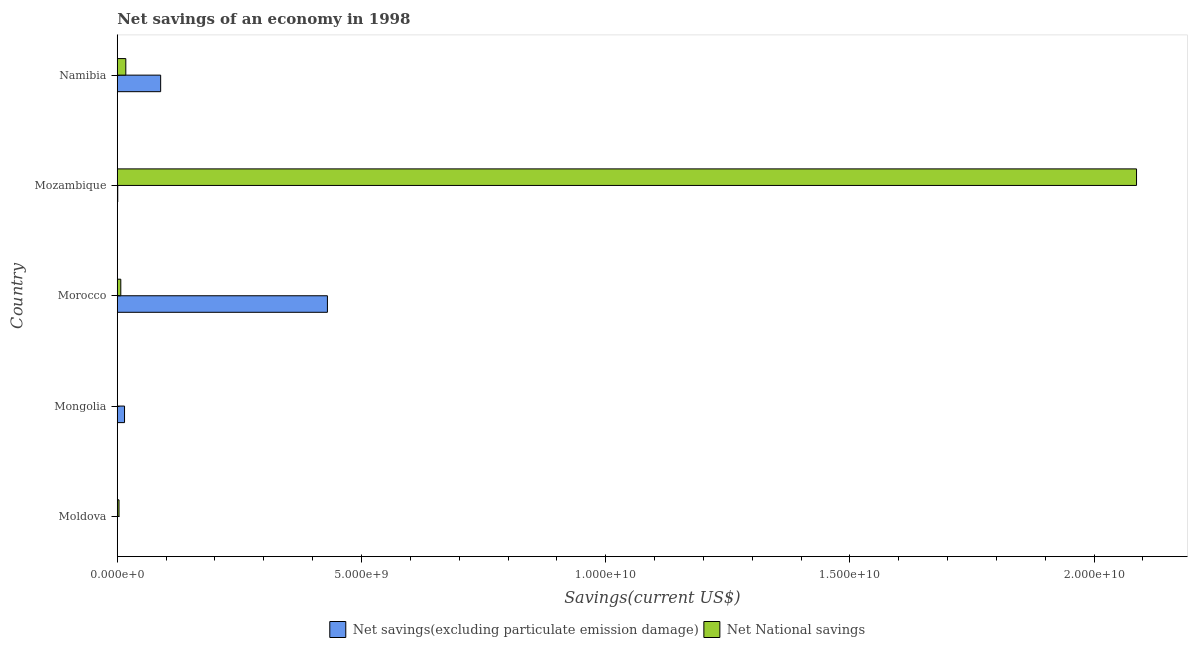How many different coloured bars are there?
Give a very brief answer. 2. Are the number of bars per tick equal to the number of legend labels?
Provide a succinct answer. No. How many bars are there on the 1st tick from the top?
Ensure brevity in your answer.  2. What is the label of the 1st group of bars from the top?
Provide a succinct answer. Namibia. In how many cases, is the number of bars for a given country not equal to the number of legend labels?
Make the answer very short. 2. What is the net national savings in Mongolia?
Keep it short and to the point. 0. Across all countries, what is the maximum net savings(excluding particulate emission damage)?
Give a very brief answer. 4.30e+09. Across all countries, what is the minimum net national savings?
Provide a succinct answer. 0. In which country was the net savings(excluding particulate emission damage) maximum?
Provide a short and direct response. Morocco. What is the total net national savings in the graph?
Your answer should be compact. 2.12e+1. What is the difference between the net savings(excluding particulate emission damage) in Mozambique and that in Namibia?
Offer a very short reply. -8.78e+08. What is the difference between the net national savings in Mongolia and the net savings(excluding particulate emission damage) in Morocco?
Your response must be concise. -4.30e+09. What is the average net national savings per country?
Make the answer very short. 4.23e+09. What is the difference between the net savings(excluding particulate emission damage) and net national savings in Mozambique?
Your response must be concise. -2.09e+1. In how many countries, is the net national savings greater than 14000000000 US$?
Give a very brief answer. 1. What is the ratio of the net national savings in Moldova to that in Namibia?
Your answer should be compact. 0.2. Is the net savings(excluding particulate emission damage) in Morocco less than that in Mozambique?
Offer a terse response. No. What is the difference between the highest and the second highest net national savings?
Offer a very short reply. 2.07e+1. What is the difference between the highest and the lowest net savings(excluding particulate emission damage)?
Ensure brevity in your answer.  4.30e+09. In how many countries, is the net savings(excluding particulate emission damage) greater than the average net savings(excluding particulate emission damage) taken over all countries?
Provide a succinct answer. 1. Is the sum of the net savings(excluding particulate emission damage) in Mongolia and Namibia greater than the maximum net national savings across all countries?
Offer a very short reply. No. How many bars are there?
Keep it short and to the point. 8. Does the graph contain any zero values?
Your answer should be compact. Yes. Does the graph contain grids?
Provide a succinct answer. No. Where does the legend appear in the graph?
Ensure brevity in your answer.  Bottom center. What is the title of the graph?
Ensure brevity in your answer.  Net savings of an economy in 1998. Does "Death rate" appear as one of the legend labels in the graph?
Ensure brevity in your answer.  No. What is the label or title of the X-axis?
Offer a terse response. Savings(current US$). What is the Savings(current US$) of Net National savings in Moldova?
Ensure brevity in your answer.  3.56e+07. What is the Savings(current US$) in Net savings(excluding particulate emission damage) in Mongolia?
Provide a succinct answer. 1.48e+08. What is the Savings(current US$) of Net National savings in Mongolia?
Your response must be concise. 0. What is the Savings(current US$) of Net savings(excluding particulate emission damage) in Morocco?
Keep it short and to the point. 4.30e+09. What is the Savings(current US$) in Net National savings in Morocco?
Ensure brevity in your answer.  7.19e+07. What is the Savings(current US$) in Net savings(excluding particulate emission damage) in Mozambique?
Make the answer very short. 9.62e+06. What is the Savings(current US$) in Net National savings in Mozambique?
Provide a succinct answer. 2.09e+1. What is the Savings(current US$) in Net savings(excluding particulate emission damage) in Namibia?
Your response must be concise. 8.88e+08. What is the Savings(current US$) of Net National savings in Namibia?
Offer a very short reply. 1.75e+08. Across all countries, what is the maximum Savings(current US$) in Net savings(excluding particulate emission damage)?
Keep it short and to the point. 4.30e+09. Across all countries, what is the maximum Savings(current US$) of Net National savings?
Give a very brief answer. 2.09e+1. Across all countries, what is the minimum Savings(current US$) of Net savings(excluding particulate emission damage)?
Provide a succinct answer. 0. Across all countries, what is the minimum Savings(current US$) in Net National savings?
Offer a very short reply. 0. What is the total Savings(current US$) in Net savings(excluding particulate emission damage) in the graph?
Your answer should be very brief. 5.35e+09. What is the total Savings(current US$) in Net National savings in the graph?
Make the answer very short. 2.12e+1. What is the difference between the Savings(current US$) in Net National savings in Moldova and that in Morocco?
Give a very brief answer. -3.63e+07. What is the difference between the Savings(current US$) in Net National savings in Moldova and that in Mozambique?
Offer a terse response. -2.08e+1. What is the difference between the Savings(current US$) of Net National savings in Moldova and that in Namibia?
Ensure brevity in your answer.  -1.39e+08. What is the difference between the Savings(current US$) in Net savings(excluding particulate emission damage) in Mongolia and that in Morocco?
Your answer should be very brief. -4.15e+09. What is the difference between the Savings(current US$) in Net savings(excluding particulate emission damage) in Mongolia and that in Mozambique?
Make the answer very short. 1.39e+08. What is the difference between the Savings(current US$) of Net savings(excluding particulate emission damage) in Mongolia and that in Namibia?
Keep it short and to the point. -7.40e+08. What is the difference between the Savings(current US$) in Net savings(excluding particulate emission damage) in Morocco and that in Mozambique?
Ensure brevity in your answer.  4.29e+09. What is the difference between the Savings(current US$) in Net National savings in Morocco and that in Mozambique?
Keep it short and to the point. -2.08e+1. What is the difference between the Savings(current US$) in Net savings(excluding particulate emission damage) in Morocco and that in Namibia?
Your answer should be compact. 3.41e+09. What is the difference between the Savings(current US$) in Net National savings in Morocco and that in Namibia?
Offer a very short reply. -1.03e+08. What is the difference between the Savings(current US$) in Net savings(excluding particulate emission damage) in Mozambique and that in Namibia?
Provide a short and direct response. -8.78e+08. What is the difference between the Savings(current US$) of Net National savings in Mozambique and that in Namibia?
Offer a terse response. 2.07e+1. What is the difference between the Savings(current US$) of Net savings(excluding particulate emission damage) in Mongolia and the Savings(current US$) of Net National savings in Morocco?
Your response must be concise. 7.65e+07. What is the difference between the Savings(current US$) in Net savings(excluding particulate emission damage) in Mongolia and the Savings(current US$) in Net National savings in Mozambique?
Your answer should be compact. -2.07e+1. What is the difference between the Savings(current US$) of Net savings(excluding particulate emission damage) in Mongolia and the Savings(current US$) of Net National savings in Namibia?
Provide a short and direct response. -2.62e+07. What is the difference between the Savings(current US$) of Net savings(excluding particulate emission damage) in Morocco and the Savings(current US$) of Net National savings in Mozambique?
Give a very brief answer. -1.66e+1. What is the difference between the Savings(current US$) of Net savings(excluding particulate emission damage) in Morocco and the Savings(current US$) of Net National savings in Namibia?
Offer a terse response. 4.13e+09. What is the difference between the Savings(current US$) in Net savings(excluding particulate emission damage) in Mozambique and the Savings(current US$) in Net National savings in Namibia?
Your answer should be compact. -1.65e+08. What is the average Savings(current US$) in Net savings(excluding particulate emission damage) per country?
Your response must be concise. 1.07e+09. What is the average Savings(current US$) in Net National savings per country?
Your answer should be compact. 4.23e+09. What is the difference between the Savings(current US$) of Net savings(excluding particulate emission damage) and Savings(current US$) of Net National savings in Morocco?
Ensure brevity in your answer.  4.23e+09. What is the difference between the Savings(current US$) of Net savings(excluding particulate emission damage) and Savings(current US$) of Net National savings in Mozambique?
Keep it short and to the point. -2.09e+1. What is the difference between the Savings(current US$) of Net savings(excluding particulate emission damage) and Savings(current US$) of Net National savings in Namibia?
Provide a succinct answer. 7.14e+08. What is the ratio of the Savings(current US$) in Net National savings in Moldova to that in Morocco?
Provide a succinct answer. 0.49. What is the ratio of the Savings(current US$) in Net National savings in Moldova to that in Mozambique?
Your response must be concise. 0. What is the ratio of the Savings(current US$) in Net National savings in Moldova to that in Namibia?
Provide a succinct answer. 0.2. What is the ratio of the Savings(current US$) in Net savings(excluding particulate emission damage) in Mongolia to that in Morocco?
Give a very brief answer. 0.03. What is the ratio of the Savings(current US$) of Net savings(excluding particulate emission damage) in Mongolia to that in Mozambique?
Make the answer very short. 15.42. What is the ratio of the Savings(current US$) in Net savings(excluding particulate emission damage) in Mongolia to that in Namibia?
Offer a very short reply. 0.17. What is the ratio of the Savings(current US$) of Net savings(excluding particulate emission damage) in Morocco to that in Mozambique?
Ensure brevity in your answer.  447.22. What is the ratio of the Savings(current US$) in Net National savings in Morocco to that in Mozambique?
Keep it short and to the point. 0. What is the ratio of the Savings(current US$) of Net savings(excluding particulate emission damage) in Morocco to that in Namibia?
Your answer should be very brief. 4.84. What is the ratio of the Savings(current US$) of Net National savings in Morocco to that in Namibia?
Ensure brevity in your answer.  0.41. What is the ratio of the Savings(current US$) in Net savings(excluding particulate emission damage) in Mozambique to that in Namibia?
Make the answer very short. 0.01. What is the ratio of the Savings(current US$) of Net National savings in Mozambique to that in Namibia?
Provide a short and direct response. 119.55. What is the difference between the highest and the second highest Savings(current US$) in Net savings(excluding particulate emission damage)?
Keep it short and to the point. 3.41e+09. What is the difference between the highest and the second highest Savings(current US$) of Net National savings?
Offer a terse response. 2.07e+1. What is the difference between the highest and the lowest Savings(current US$) of Net savings(excluding particulate emission damage)?
Make the answer very short. 4.30e+09. What is the difference between the highest and the lowest Savings(current US$) of Net National savings?
Ensure brevity in your answer.  2.09e+1. 